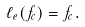<formula> <loc_0><loc_0><loc_500><loc_500>\ell _ { e } ( f _ { c } ) = f _ { c } .</formula> 